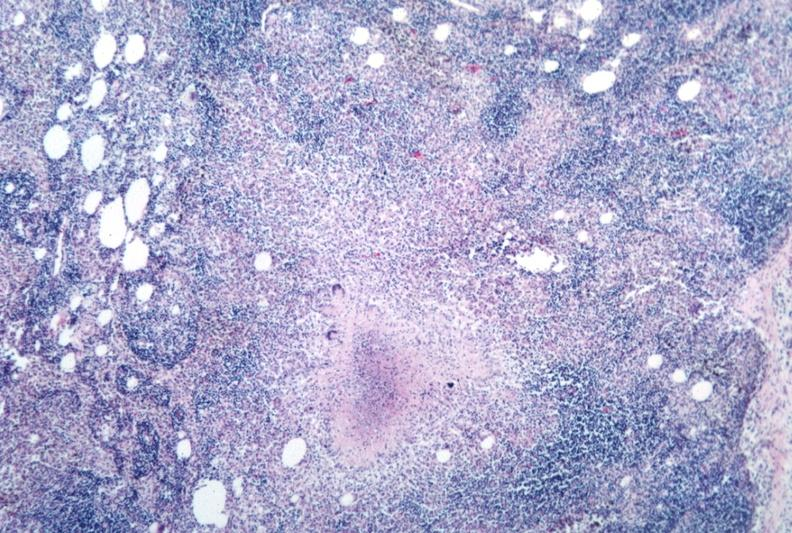does this image show necrotizing granuloma?
Answer the question using a single word or phrase. Yes 